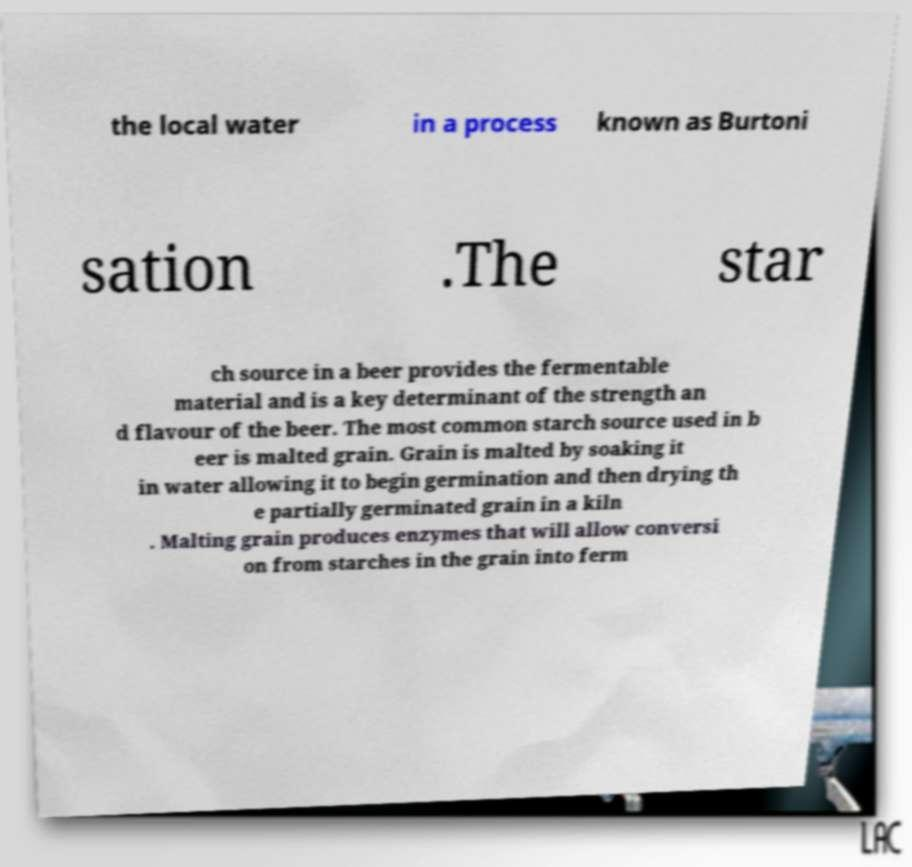There's text embedded in this image that I need extracted. Can you transcribe it verbatim? the local water in a process known as Burtoni sation .The star ch source in a beer provides the fermentable material and is a key determinant of the strength an d flavour of the beer. The most common starch source used in b eer is malted grain. Grain is malted by soaking it in water allowing it to begin germination and then drying th e partially germinated grain in a kiln . Malting grain produces enzymes that will allow conversi on from starches in the grain into ferm 